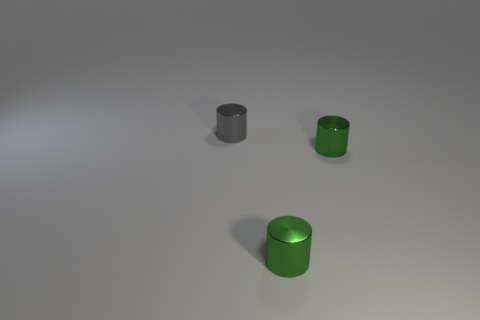Add 2 gray cylinders. How many objects exist? 5 Subtract 0 yellow cylinders. How many objects are left? 3 Subtract all tiny gray objects. Subtract all green cylinders. How many objects are left? 0 Add 1 tiny gray cylinders. How many tiny gray cylinders are left? 2 Add 3 brown cubes. How many brown cubes exist? 3 